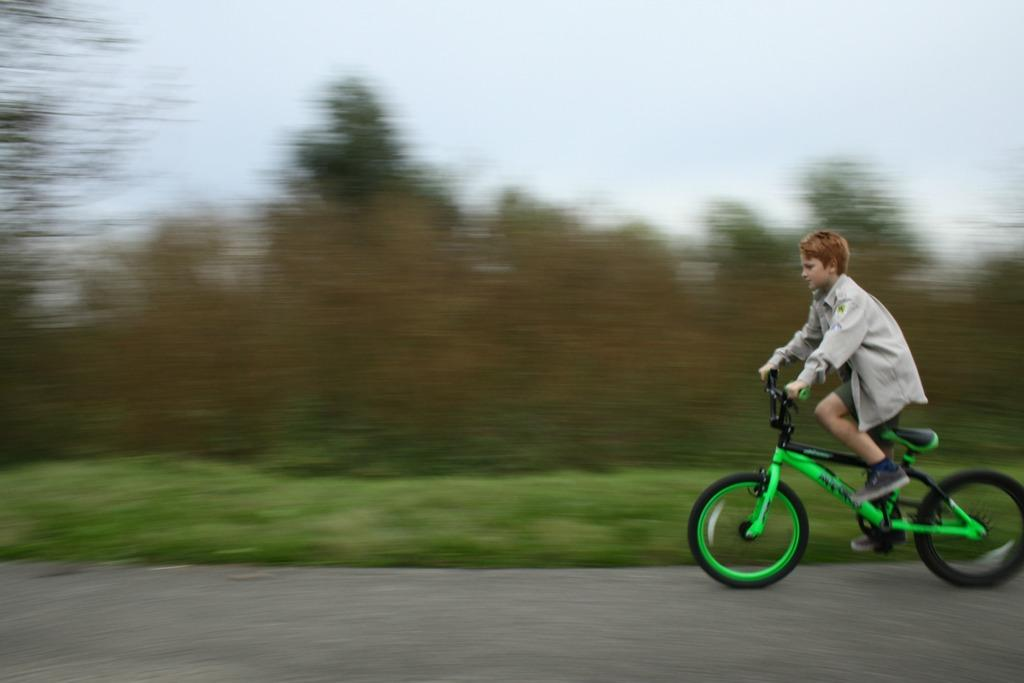Who is the main subject in the image? There is a boy in the image. What is the boy doing in the image? The boy is riding a bicycle. What can be seen in the background of the image? There are trees, plants, grass, and the sky visible in the background of the image. What type of tax is being discussed by the judge in the image? There is no judge or tax discussion present in the image; it features a boy riding a bicycle. How many chairs are visible in the image? There are no chairs visible in the image; it features a boy riding a bicycle in a natural setting. 